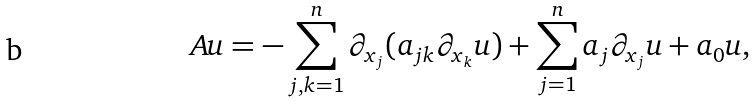Convert formula to latex. <formula><loc_0><loc_0><loc_500><loc_500>A u = - \sum _ { j , k = 1 } ^ { n } \partial _ { x _ { j } } ( a _ { j k } \partial _ { x _ { k } } u ) + \sum _ { j = 1 } ^ { n } a _ { j } \partial _ { x _ { j } } u + a _ { 0 } u ,</formula> 